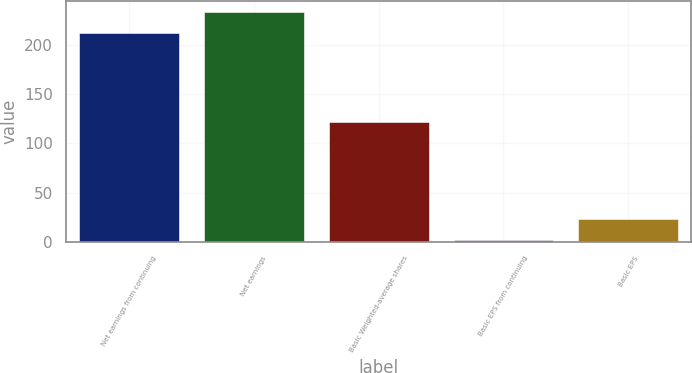Convert chart to OTSL. <chart><loc_0><loc_0><loc_500><loc_500><bar_chart><fcel>Net earnings from continuing<fcel>Net earnings<fcel>Basic Weighted-average shares<fcel>Basic EPS from continuing<fcel>Basic EPS<nl><fcel>212.1<fcel>233.14<fcel>121.9<fcel>1.74<fcel>22.78<nl></chart> 